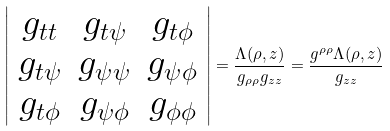<formula> <loc_0><loc_0><loc_500><loc_500>\left | \begin{array} { c c c } g _ { t t } & g _ { t \psi } & g _ { t \phi } \\ g _ { t \psi } & g _ { \psi \psi } & g _ { \psi \phi } \\ g _ { t \phi } & g _ { \psi \phi } & g _ { \phi \phi } \end{array} \right | = \frac { \Lambda ( \rho , z ) } { g _ { \rho \rho } g _ { z z } } = \frac { g ^ { \rho \rho } \Lambda ( \rho , z ) } { g _ { z z } }</formula> 